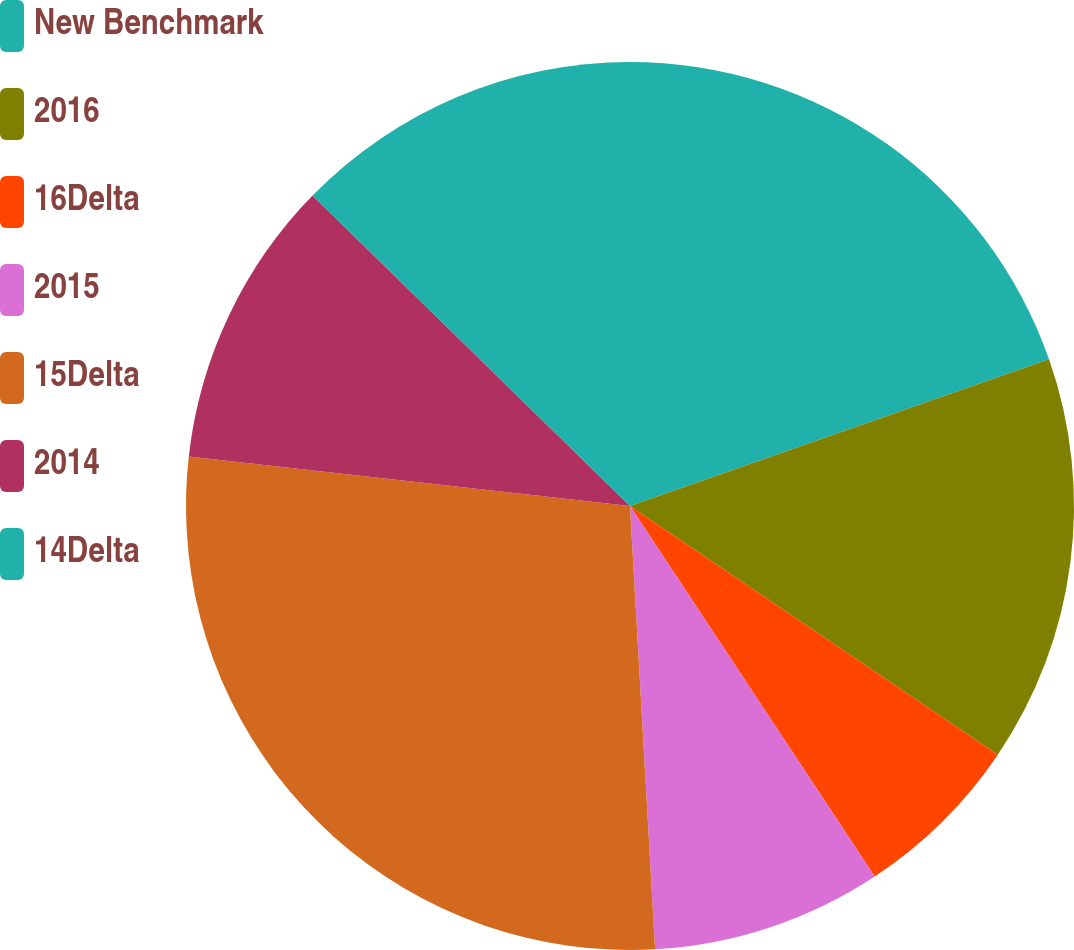Convert chart. <chart><loc_0><loc_0><loc_500><loc_500><pie_chart><fcel>New Benchmark<fcel>2016<fcel>16Delta<fcel>2015<fcel>15Delta<fcel>2014<fcel>14Delta<nl><fcel>19.64%<fcel>14.82%<fcel>6.25%<fcel>8.39%<fcel>27.68%<fcel>10.54%<fcel>12.68%<nl></chart> 